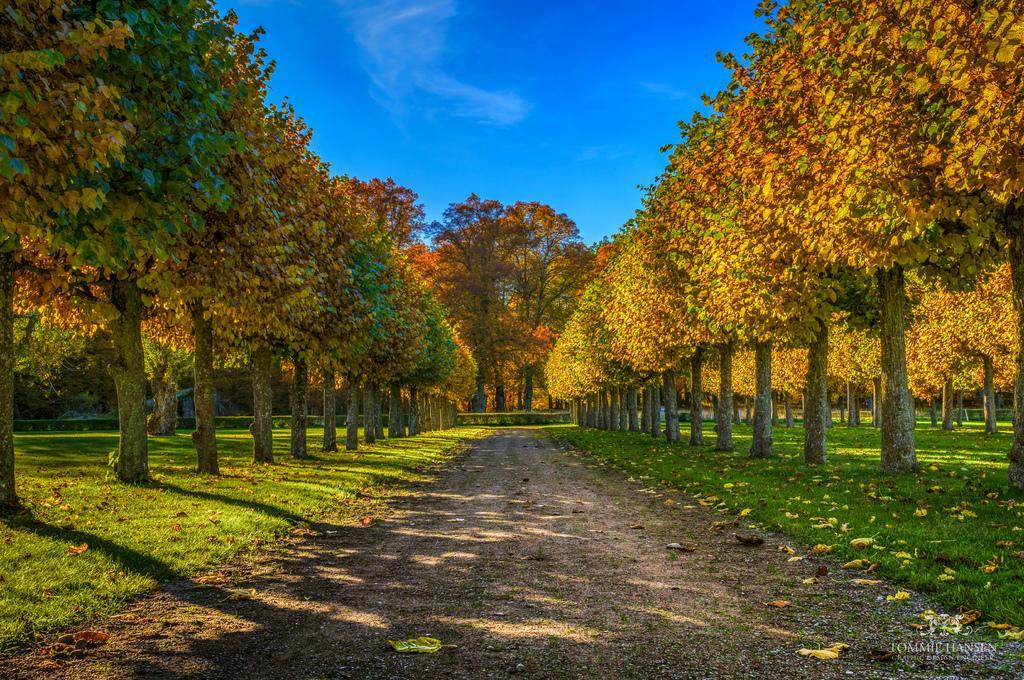Please provide a concise description of this image. There are trees on a grassy land in the middle of this image. The blue sky is in the background. 